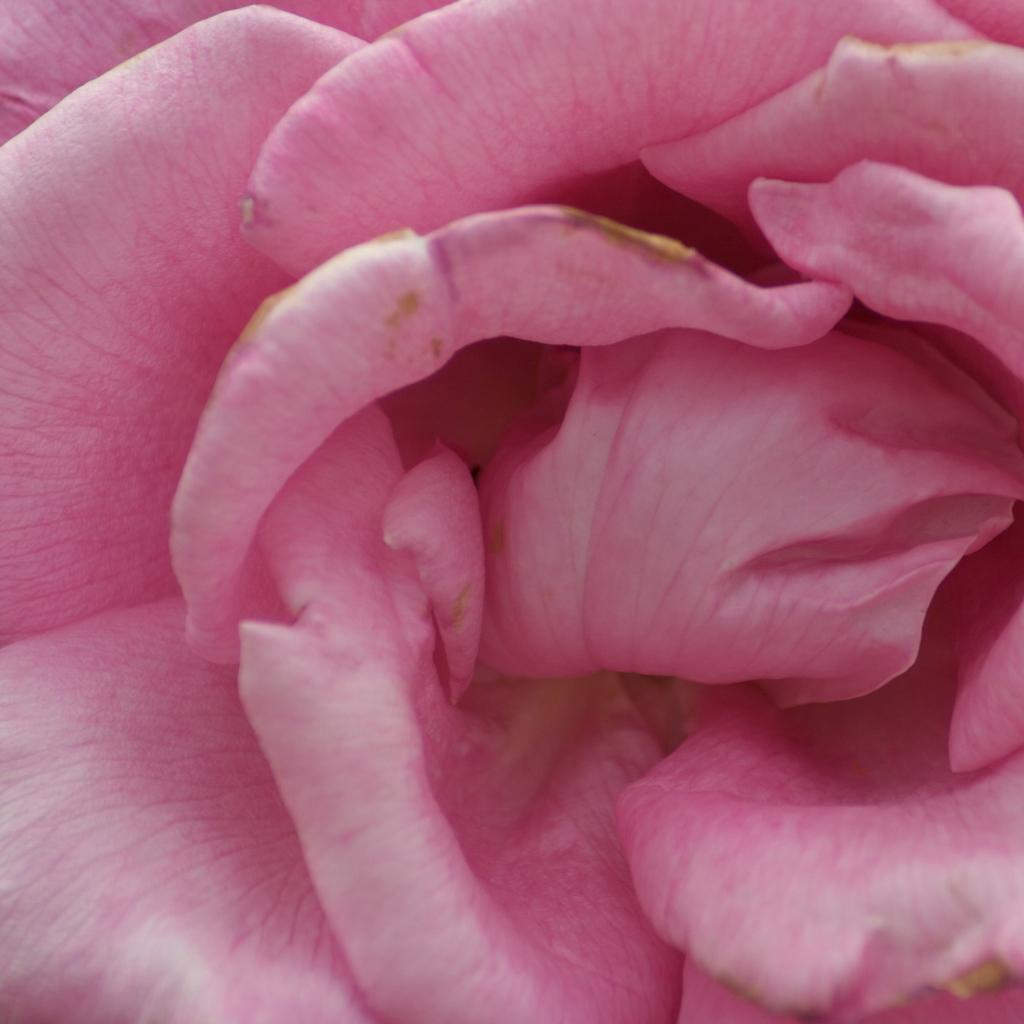What type of flower is in the image? There is a pink color rose in the image. What type of butter can be seen on the neck of the rose in the image? There is no butter present in the image, and the rose does not have a neck. 